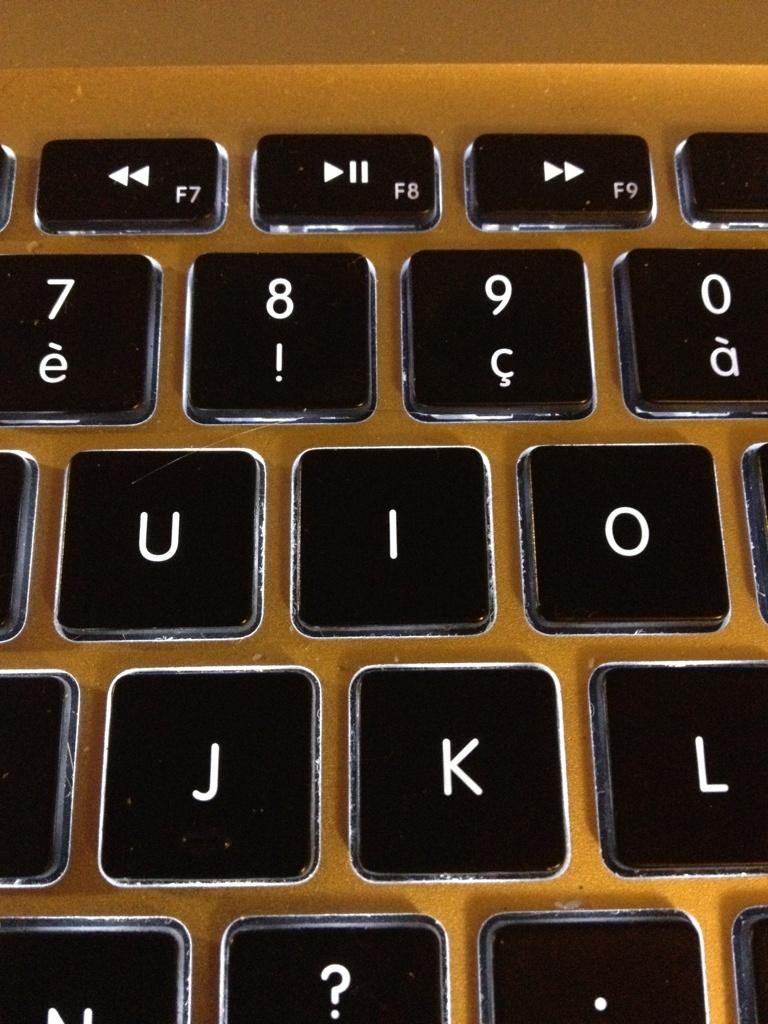<image>
Give a short and clear explanation of the subsequent image. a keyboard close up shows keys J and I 